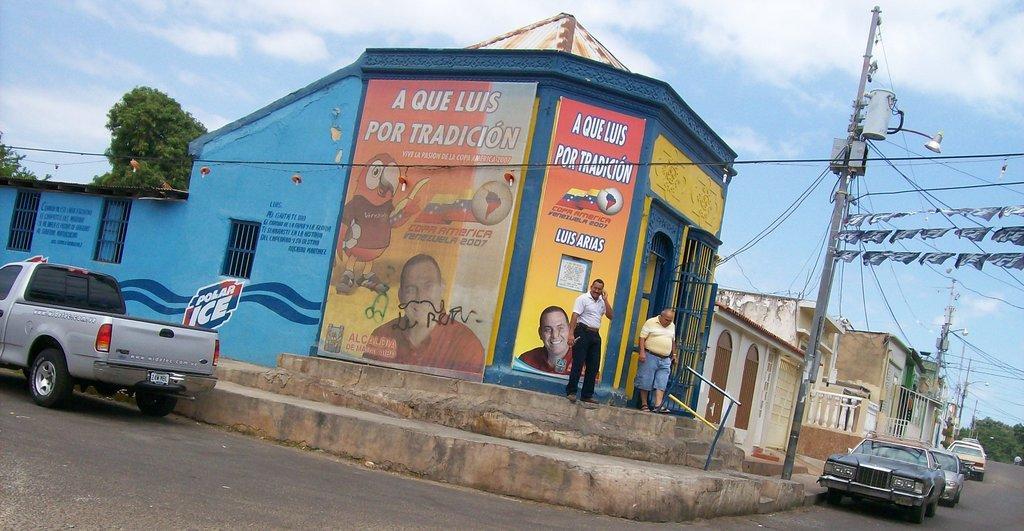Could you give a brief overview of what you see in this image? In this picture we can observe a road. There are some cars on the road. We can observe a building on which there are some advertisements on the wall. There are two persons standing on the steps. There is a pole on the right side. We can observe some buildings. In the background there are trees and a sky with some clouds. 